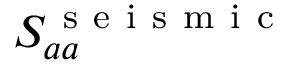Convert formula to latex. <formula><loc_0><loc_0><loc_500><loc_500>S _ { a a } ^ { s e i s m i c }</formula> 